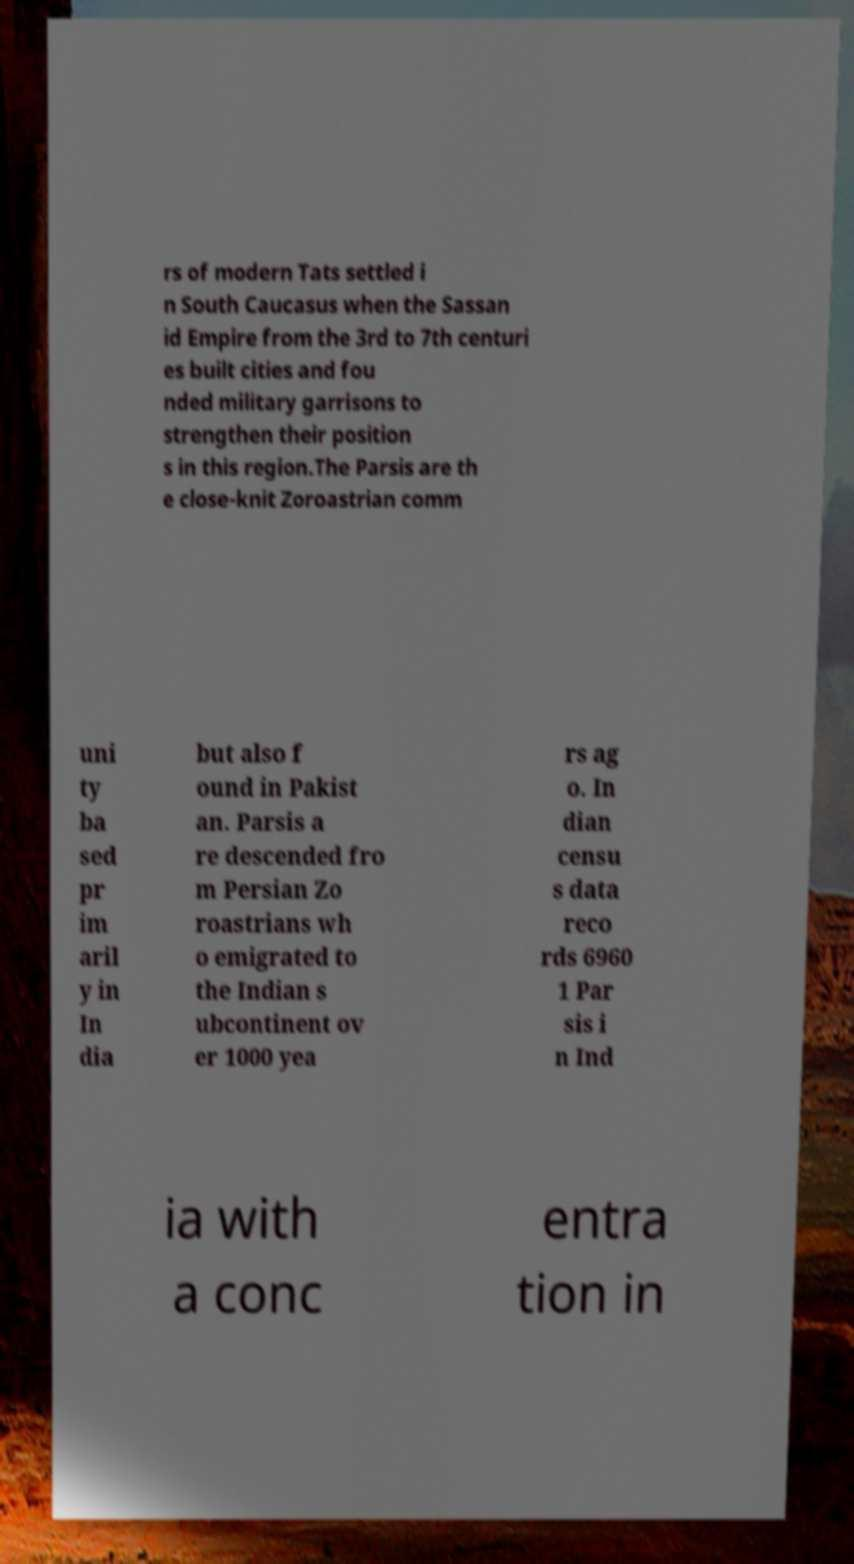Please identify and transcribe the text found in this image. rs of modern Tats settled i n South Caucasus when the Sassan id Empire from the 3rd to 7th centuri es built cities and fou nded military garrisons to strengthen their position s in this region.The Parsis are th e close-knit Zoroastrian comm uni ty ba sed pr im aril y in In dia but also f ound in Pakist an. Parsis a re descended fro m Persian Zo roastrians wh o emigrated to the Indian s ubcontinent ov er 1000 yea rs ag o. In dian censu s data reco rds 6960 1 Par sis i n Ind ia with a conc entra tion in 